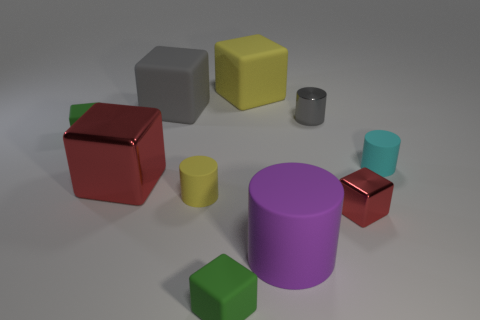The thing that is the same color as the metal cylinder is what size?
Offer a very short reply. Large. Are there any other things of the same color as the large shiny thing?
Your response must be concise. Yes. There is a small matte thing left of the large block in front of the green matte object to the left of the tiny yellow cylinder; what is its color?
Your answer should be very brief. Green. There is a red block that is to the right of the tiny matte block that is to the right of the tiny yellow rubber object; how big is it?
Provide a succinct answer. Small. What is the material of the cylinder that is on the left side of the tiny gray thing and to the right of the small yellow cylinder?
Keep it short and to the point. Rubber. Is the size of the gray metallic object the same as the red metallic block that is on the right side of the gray block?
Offer a very short reply. Yes. Are there any small shiny cylinders?
Keep it short and to the point. Yes. There is a yellow object that is the same shape as the small red thing; what material is it?
Give a very brief answer. Rubber. There is a green matte thing that is to the right of the green cube that is left of the small green matte thing in front of the big purple rubber cylinder; how big is it?
Your answer should be very brief. Small. There is a yellow matte cylinder; are there any cylinders behind it?
Your answer should be compact. Yes. 